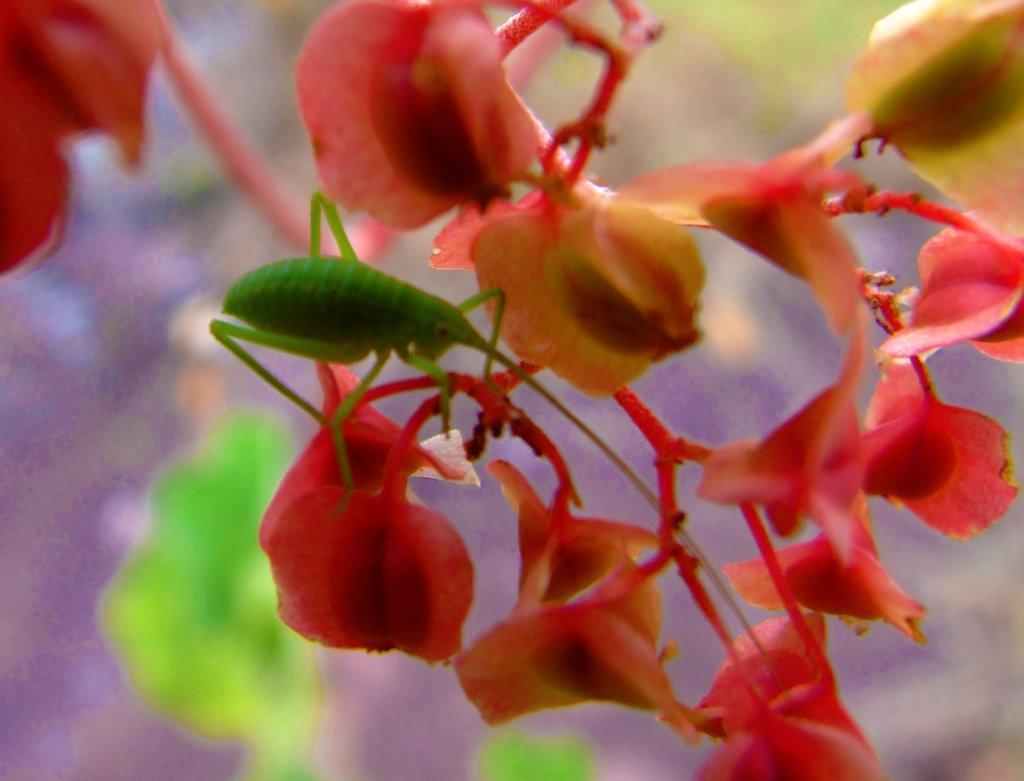What type of living organism can be seen in the image? There is an insect in the image. What other natural elements are present in the image? There are flowers in the image. Can you describe the background of the image? The background of the image is blurred. What type of team is responsible for maintaining the bushes in the image? There are no bushes present in the image, and therefore no team is responsible for maintaining them. 